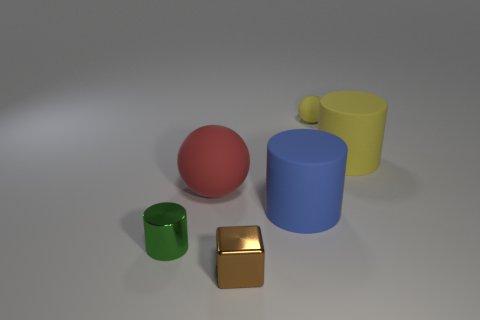There is a metal cylinder; what number of small metallic objects are behind it?
Offer a very short reply. 0. What color is the matte sphere that is in front of the rubber cylinder behind the blue matte cylinder?
Offer a terse response. Red. Is there anything else that is the same shape as the brown thing?
Offer a terse response. No. Is the number of cylinders on the right side of the red matte object the same as the number of tiny brown things that are behind the big blue matte thing?
Your answer should be compact. No. What number of balls are either yellow objects or shiny things?
Offer a terse response. 1. How many other objects are the same material as the big red sphere?
Offer a very short reply. 3. There is a big rubber thing that is right of the small yellow rubber sphere; what shape is it?
Ensure brevity in your answer.  Cylinder. There is a tiny cylinder to the left of the big matte thing right of the small ball; what is it made of?
Provide a succinct answer. Metal. Is the number of balls behind the big sphere greater than the number of large green metallic balls?
Offer a terse response. Yes. What number of other things are there of the same color as the big matte ball?
Provide a short and direct response. 0. 